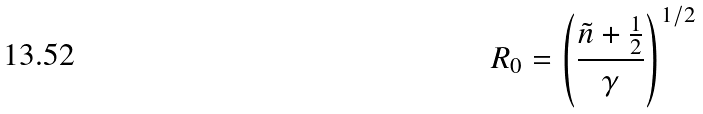Convert formula to latex. <formula><loc_0><loc_0><loc_500><loc_500>R _ { 0 } = \left ( \frac { { \tilde { n } } + \frac { 1 } { 2 } } { \gamma } \right ) ^ { 1 / 2 }</formula> 